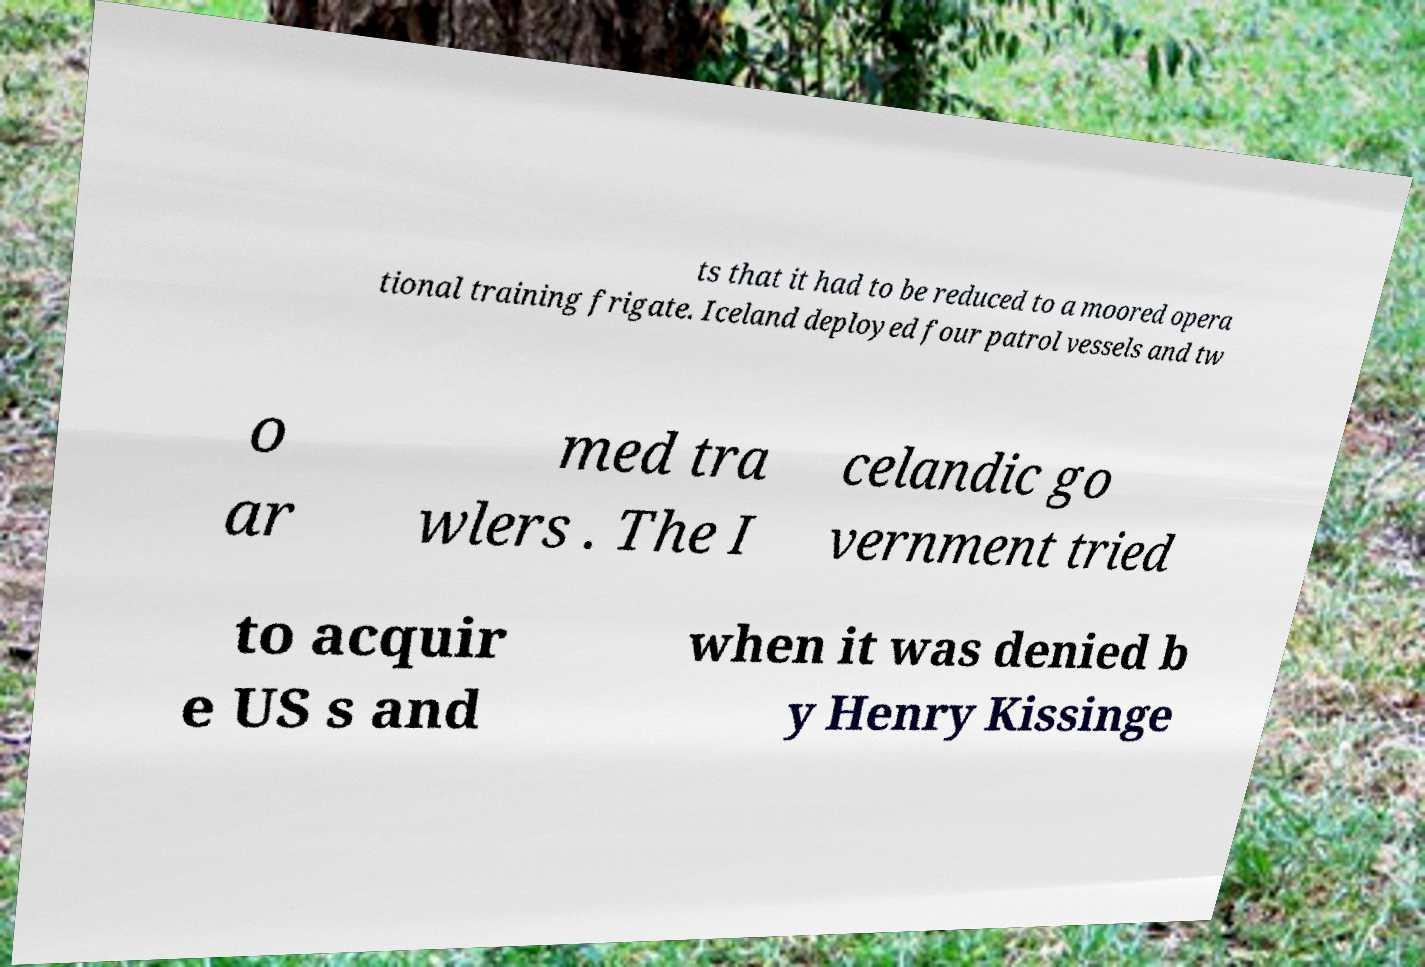Please read and relay the text visible in this image. What does it say? ts that it had to be reduced to a moored opera tional training frigate. Iceland deployed four patrol vessels and tw o ar med tra wlers . The I celandic go vernment tried to acquir e US s and when it was denied b y Henry Kissinge 